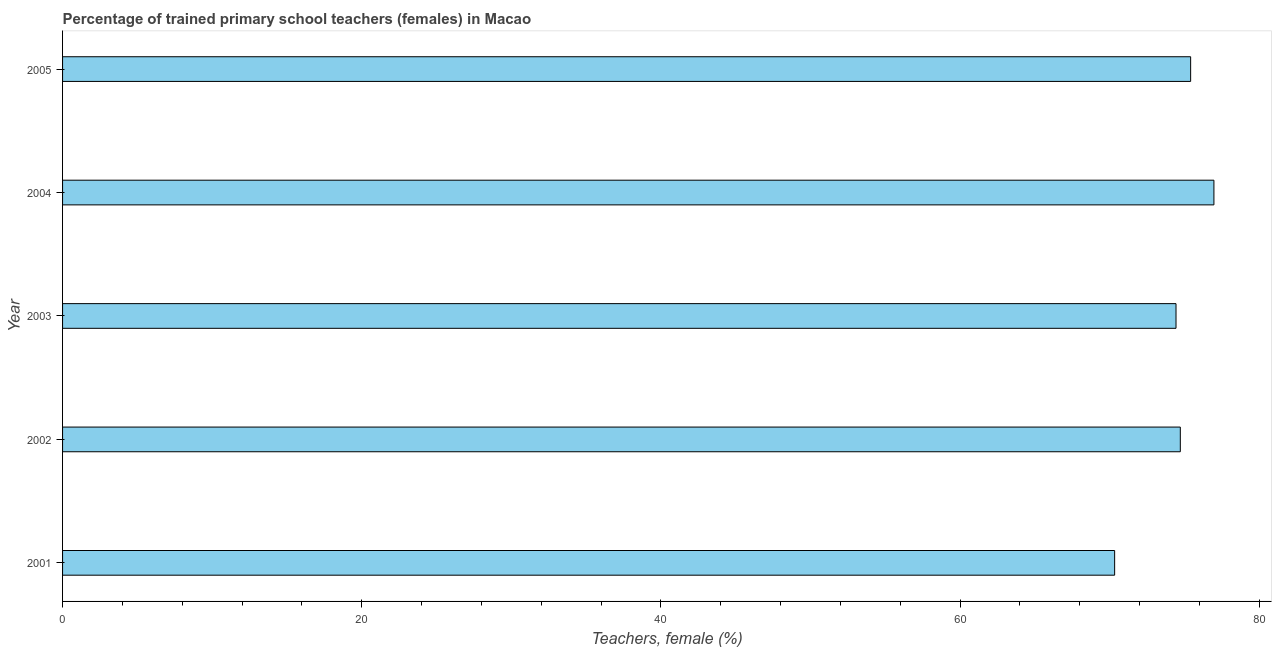Does the graph contain any zero values?
Your answer should be very brief. No. What is the title of the graph?
Your answer should be compact. Percentage of trained primary school teachers (females) in Macao. What is the label or title of the X-axis?
Your response must be concise. Teachers, female (%). What is the percentage of trained female teachers in 2002?
Your answer should be very brief. 74.72. Across all years, what is the maximum percentage of trained female teachers?
Your response must be concise. 76.97. Across all years, what is the minimum percentage of trained female teachers?
Your response must be concise. 70.33. In which year was the percentage of trained female teachers maximum?
Give a very brief answer. 2004. What is the sum of the percentage of trained female teachers?
Your answer should be compact. 371.86. What is the difference between the percentage of trained female teachers in 2002 and 2003?
Provide a short and direct response. 0.29. What is the average percentage of trained female teachers per year?
Provide a succinct answer. 74.37. What is the median percentage of trained female teachers?
Offer a terse response. 74.72. What is the ratio of the percentage of trained female teachers in 2002 to that in 2004?
Give a very brief answer. 0.97. Is the difference between the percentage of trained female teachers in 2002 and 2004 greater than the difference between any two years?
Give a very brief answer. No. What is the difference between the highest and the second highest percentage of trained female teachers?
Keep it short and to the point. 1.56. Is the sum of the percentage of trained female teachers in 2003 and 2005 greater than the maximum percentage of trained female teachers across all years?
Offer a terse response. Yes. What is the difference between the highest and the lowest percentage of trained female teachers?
Offer a terse response. 6.64. In how many years, is the percentage of trained female teachers greater than the average percentage of trained female teachers taken over all years?
Make the answer very short. 4. How many bars are there?
Give a very brief answer. 5. What is the difference between two consecutive major ticks on the X-axis?
Ensure brevity in your answer.  20. What is the Teachers, female (%) of 2001?
Keep it short and to the point. 70.33. What is the Teachers, female (%) of 2002?
Provide a short and direct response. 74.72. What is the Teachers, female (%) of 2003?
Provide a short and direct response. 74.43. What is the Teachers, female (%) of 2004?
Offer a very short reply. 76.97. What is the Teachers, female (%) in 2005?
Provide a short and direct response. 75.41. What is the difference between the Teachers, female (%) in 2001 and 2002?
Keep it short and to the point. -4.39. What is the difference between the Teachers, female (%) in 2001 and 2003?
Provide a succinct answer. -4.1. What is the difference between the Teachers, female (%) in 2001 and 2004?
Give a very brief answer. -6.64. What is the difference between the Teachers, female (%) in 2001 and 2005?
Your answer should be very brief. -5.08. What is the difference between the Teachers, female (%) in 2002 and 2003?
Your answer should be very brief. 0.29. What is the difference between the Teachers, female (%) in 2002 and 2004?
Provide a succinct answer. -2.25. What is the difference between the Teachers, female (%) in 2002 and 2005?
Make the answer very short. -0.69. What is the difference between the Teachers, female (%) in 2003 and 2004?
Provide a succinct answer. -2.53. What is the difference between the Teachers, female (%) in 2003 and 2005?
Keep it short and to the point. -0.98. What is the difference between the Teachers, female (%) in 2004 and 2005?
Offer a very short reply. 1.56. What is the ratio of the Teachers, female (%) in 2001 to that in 2002?
Your answer should be compact. 0.94. What is the ratio of the Teachers, female (%) in 2001 to that in 2003?
Your answer should be very brief. 0.94. What is the ratio of the Teachers, female (%) in 2001 to that in 2004?
Provide a succinct answer. 0.91. What is the ratio of the Teachers, female (%) in 2001 to that in 2005?
Provide a succinct answer. 0.93. What is the ratio of the Teachers, female (%) in 2002 to that in 2003?
Provide a succinct answer. 1. What is the ratio of the Teachers, female (%) in 2002 to that in 2004?
Offer a very short reply. 0.97. What is the ratio of the Teachers, female (%) in 2002 to that in 2005?
Provide a short and direct response. 0.99. What is the ratio of the Teachers, female (%) in 2003 to that in 2004?
Your answer should be very brief. 0.97. What is the ratio of the Teachers, female (%) in 2004 to that in 2005?
Give a very brief answer. 1.02. 